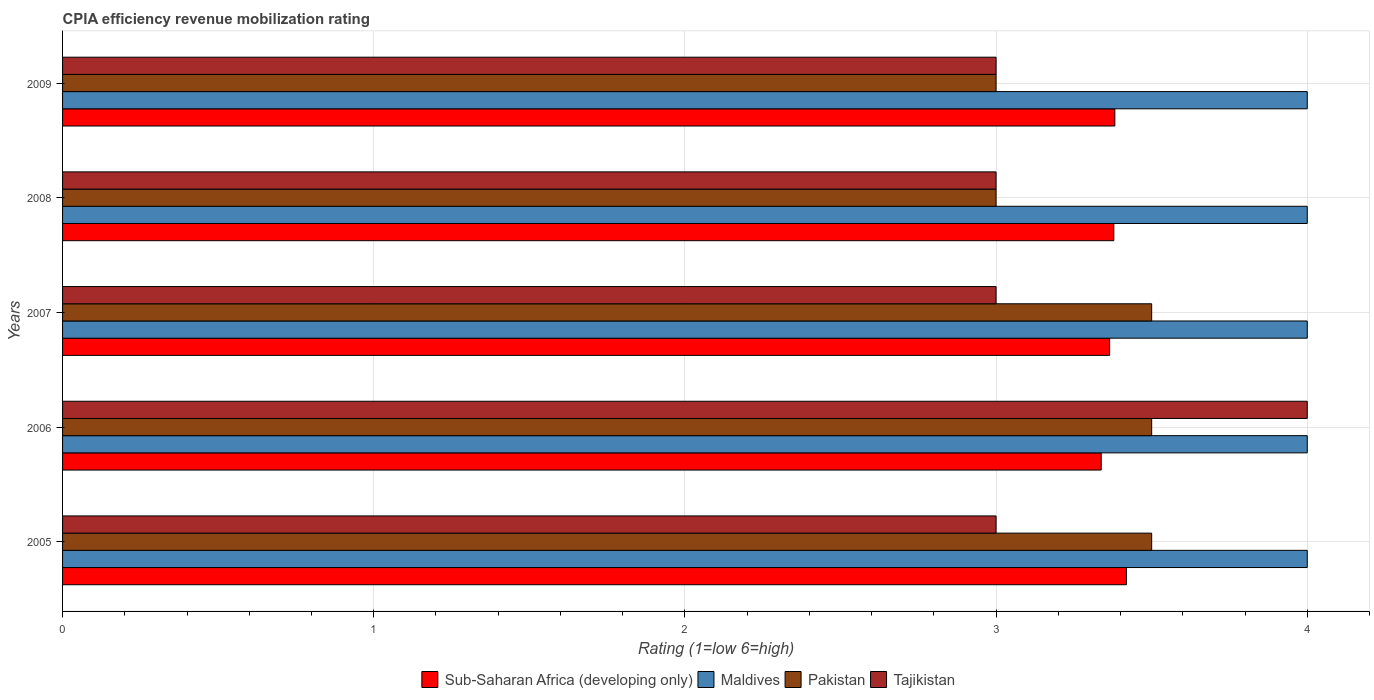How many groups of bars are there?
Keep it short and to the point. 5. Are the number of bars per tick equal to the number of legend labels?
Ensure brevity in your answer.  Yes. Are the number of bars on each tick of the Y-axis equal?
Offer a very short reply. Yes. How many bars are there on the 3rd tick from the top?
Offer a terse response. 4. What is the CPIA rating in Tajikistan in 2005?
Offer a very short reply. 3. Across all years, what is the maximum CPIA rating in Sub-Saharan Africa (developing only)?
Your response must be concise. 3.42. Across all years, what is the minimum CPIA rating in Pakistan?
Offer a very short reply. 3. In which year was the CPIA rating in Maldives maximum?
Ensure brevity in your answer.  2005. What is the difference between the CPIA rating in Sub-Saharan Africa (developing only) in 2005 and that in 2009?
Provide a short and direct response. 0.04. What is the difference between the CPIA rating in Pakistan in 2006 and the CPIA rating in Maldives in 2009?
Your answer should be very brief. -0.5. What is the average CPIA rating in Pakistan per year?
Your answer should be compact. 3.3. In the year 2009, what is the difference between the CPIA rating in Maldives and CPIA rating in Sub-Saharan Africa (developing only)?
Make the answer very short. 0.62. In how many years, is the CPIA rating in Tajikistan greater than 0.2 ?
Your response must be concise. 5. What is the ratio of the CPIA rating in Pakistan in 2007 to that in 2008?
Your answer should be compact. 1.17. What is the difference between the highest and the second highest CPIA rating in Sub-Saharan Africa (developing only)?
Your answer should be very brief. 0.04. What does the 3rd bar from the top in 2008 represents?
Provide a short and direct response. Maldives. What does the 4th bar from the bottom in 2008 represents?
Your answer should be very brief. Tajikistan. Is it the case that in every year, the sum of the CPIA rating in Maldives and CPIA rating in Tajikistan is greater than the CPIA rating in Pakistan?
Your answer should be very brief. Yes. How many bars are there?
Provide a succinct answer. 20. How many years are there in the graph?
Offer a very short reply. 5. What is the difference between two consecutive major ticks on the X-axis?
Keep it short and to the point. 1. Are the values on the major ticks of X-axis written in scientific E-notation?
Make the answer very short. No. Where does the legend appear in the graph?
Give a very brief answer. Bottom center. How many legend labels are there?
Make the answer very short. 4. How are the legend labels stacked?
Provide a succinct answer. Horizontal. What is the title of the graph?
Provide a succinct answer. CPIA efficiency revenue mobilization rating. What is the Rating (1=low 6=high) of Sub-Saharan Africa (developing only) in 2005?
Your response must be concise. 3.42. What is the Rating (1=low 6=high) of Pakistan in 2005?
Keep it short and to the point. 3.5. What is the Rating (1=low 6=high) of Sub-Saharan Africa (developing only) in 2006?
Provide a short and direct response. 3.34. What is the Rating (1=low 6=high) in Maldives in 2006?
Make the answer very short. 4. What is the Rating (1=low 6=high) in Pakistan in 2006?
Offer a very short reply. 3.5. What is the Rating (1=low 6=high) of Sub-Saharan Africa (developing only) in 2007?
Ensure brevity in your answer.  3.36. What is the Rating (1=low 6=high) in Pakistan in 2007?
Provide a short and direct response. 3.5. What is the Rating (1=low 6=high) in Tajikistan in 2007?
Your response must be concise. 3. What is the Rating (1=low 6=high) in Sub-Saharan Africa (developing only) in 2008?
Provide a short and direct response. 3.38. What is the Rating (1=low 6=high) of Tajikistan in 2008?
Your answer should be compact. 3. What is the Rating (1=low 6=high) of Sub-Saharan Africa (developing only) in 2009?
Keep it short and to the point. 3.38. Across all years, what is the maximum Rating (1=low 6=high) in Sub-Saharan Africa (developing only)?
Your response must be concise. 3.42. Across all years, what is the maximum Rating (1=low 6=high) in Pakistan?
Your answer should be very brief. 3.5. Across all years, what is the maximum Rating (1=low 6=high) in Tajikistan?
Ensure brevity in your answer.  4. Across all years, what is the minimum Rating (1=low 6=high) of Sub-Saharan Africa (developing only)?
Provide a short and direct response. 3.34. Across all years, what is the minimum Rating (1=low 6=high) in Maldives?
Ensure brevity in your answer.  4. Across all years, what is the minimum Rating (1=low 6=high) of Pakistan?
Keep it short and to the point. 3. What is the total Rating (1=low 6=high) of Sub-Saharan Africa (developing only) in the graph?
Give a very brief answer. 16.88. What is the total Rating (1=low 6=high) of Maldives in the graph?
Your answer should be compact. 20. What is the difference between the Rating (1=low 6=high) of Sub-Saharan Africa (developing only) in 2005 and that in 2006?
Make the answer very short. 0.08. What is the difference between the Rating (1=low 6=high) in Tajikistan in 2005 and that in 2006?
Provide a succinct answer. -1. What is the difference between the Rating (1=low 6=high) of Sub-Saharan Africa (developing only) in 2005 and that in 2007?
Your answer should be compact. 0.05. What is the difference between the Rating (1=low 6=high) in Maldives in 2005 and that in 2007?
Your response must be concise. 0. What is the difference between the Rating (1=low 6=high) in Pakistan in 2005 and that in 2007?
Offer a very short reply. 0. What is the difference between the Rating (1=low 6=high) of Sub-Saharan Africa (developing only) in 2005 and that in 2008?
Make the answer very short. 0.04. What is the difference between the Rating (1=low 6=high) of Tajikistan in 2005 and that in 2008?
Your answer should be very brief. 0. What is the difference between the Rating (1=low 6=high) in Sub-Saharan Africa (developing only) in 2005 and that in 2009?
Give a very brief answer. 0.04. What is the difference between the Rating (1=low 6=high) in Pakistan in 2005 and that in 2009?
Provide a short and direct response. 0.5. What is the difference between the Rating (1=low 6=high) of Tajikistan in 2005 and that in 2009?
Your response must be concise. 0. What is the difference between the Rating (1=low 6=high) in Sub-Saharan Africa (developing only) in 2006 and that in 2007?
Your answer should be very brief. -0.03. What is the difference between the Rating (1=low 6=high) in Pakistan in 2006 and that in 2007?
Provide a succinct answer. 0. What is the difference between the Rating (1=low 6=high) in Tajikistan in 2006 and that in 2007?
Offer a very short reply. 1. What is the difference between the Rating (1=low 6=high) of Sub-Saharan Africa (developing only) in 2006 and that in 2008?
Keep it short and to the point. -0.04. What is the difference between the Rating (1=low 6=high) in Maldives in 2006 and that in 2008?
Keep it short and to the point. 0. What is the difference between the Rating (1=low 6=high) in Pakistan in 2006 and that in 2008?
Give a very brief answer. 0.5. What is the difference between the Rating (1=low 6=high) in Tajikistan in 2006 and that in 2008?
Offer a terse response. 1. What is the difference between the Rating (1=low 6=high) in Sub-Saharan Africa (developing only) in 2006 and that in 2009?
Offer a very short reply. -0.04. What is the difference between the Rating (1=low 6=high) in Tajikistan in 2006 and that in 2009?
Keep it short and to the point. 1. What is the difference between the Rating (1=low 6=high) of Sub-Saharan Africa (developing only) in 2007 and that in 2008?
Your answer should be compact. -0.01. What is the difference between the Rating (1=low 6=high) of Maldives in 2007 and that in 2008?
Your answer should be very brief. 0. What is the difference between the Rating (1=low 6=high) of Pakistan in 2007 and that in 2008?
Your answer should be very brief. 0.5. What is the difference between the Rating (1=low 6=high) in Sub-Saharan Africa (developing only) in 2007 and that in 2009?
Provide a succinct answer. -0.02. What is the difference between the Rating (1=low 6=high) in Maldives in 2007 and that in 2009?
Your answer should be very brief. 0. What is the difference between the Rating (1=low 6=high) in Pakistan in 2007 and that in 2009?
Give a very brief answer. 0.5. What is the difference between the Rating (1=low 6=high) in Sub-Saharan Africa (developing only) in 2008 and that in 2009?
Offer a terse response. -0. What is the difference between the Rating (1=low 6=high) in Pakistan in 2008 and that in 2009?
Your response must be concise. 0. What is the difference between the Rating (1=low 6=high) in Tajikistan in 2008 and that in 2009?
Keep it short and to the point. 0. What is the difference between the Rating (1=low 6=high) in Sub-Saharan Africa (developing only) in 2005 and the Rating (1=low 6=high) in Maldives in 2006?
Offer a terse response. -0.58. What is the difference between the Rating (1=low 6=high) of Sub-Saharan Africa (developing only) in 2005 and the Rating (1=low 6=high) of Pakistan in 2006?
Ensure brevity in your answer.  -0.08. What is the difference between the Rating (1=low 6=high) in Sub-Saharan Africa (developing only) in 2005 and the Rating (1=low 6=high) in Tajikistan in 2006?
Provide a succinct answer. -0.58. What is the difference between the Rating (1=low 6=high) of Maldives in 2005 and the Rating (1=low 6=high) of Pakistan in 2006?
Provide a succinct answer. 0.5. What is the difference between the Rating (1=low 6=high) in Sub-Saharan Africa (developing only) in 2005 and the Rating (1=low 6=high) in Maldives in 2007?
Your answer should be compact. -0.58. What is the difference between the Rating (1=low 6=high) in Sub-Saharan Africa (developing only) in 2005 and the Rating (1=low 6=high) in Pakistan in 2007?
Make the answer very short. -0.08. What is the difference between the Rating (1=low 6=high) of Sub-Saharan Africa (developing only) in 2005 and the Rating (1=low 6=high) of Tajikistan in 2007?
Your response must be concise. 0.42. What is the difference between the Rating (1=low 6=high) in Maldives in 2005 and the Rating (1=low 6=high) in Tajikistan in 2007?
Offer a very short reply. 1. What is the difference between the Rating (1=low 6=high) of Sub-Saharan Africa (developing only) in 2005 and the Rating (1=low 6=high) of Maldives in 2008?
Offer a very short reply. -0.58. What is the difference between the Rating (1=low 6=high) of Sub-Saharan Africa (developing only) in 2005 and the Rating (1=low 6=high) of Pakistan in 2008?
Keep it short and to the point. 0.42. What is the difference between the Rating (1=low 6=high) in Sub-Saharan Africa (developing only) in 2005 and the Rating (1=low 6=high) in Tajikistan in 2008?
Your answer should be very brief. 0.42. What is the difference between the Rating (1=low 6=high) in Sub-Saharan Africa (developing only) in 2005 and the Rating (1=low 6=high) in Maldives in 2009?
Offer a terse response. -0.58. What is the difference between the Rating (1=low 6=high) in Sub-Saharan Africa (developing only) in 2005 and the Rating (1=low 6=high) in Pakistan in 2009?
Offer a very short reply. 0.42. What is the difference between the Rating (1=low 6=high) in Sub-Saharan Africa (developing only) in 2005 and the Rating (1=low 6=high) in Tajikistan in 2009?
Give a very brief answer. 0.42. What is the difference between the Rating (1=low 6=high) of Maldives in 2005 and the Rating (1=low 6=high) of Pakistan in 2009?
Give a very brief answer. 1. What is the difference between the Rating (1=low 6=high) in Maldives in 2005 and the Rating (1=low 6=high) in Tajikistan in 2009?
Offer a terse response. 1. What is the difference between the Rating (1=low 6=high) in Pakistan in 2005 and the Rating (1=low 6=high) in Tajikistan in 2009?
Offer a very short reply. 0.5. What is the difference between the Rating (1=low 6=high) of Sub-Saharan Africa (developing only) in 2006 and the Rating (1=low 6=high) of Maldives in 2007?
Give a very brief answer. -0.66. What is the difference between the Rating (1=low 6=high) in Sub-Saharan Africa (developing only) in 2006 and the Rating (1=low 6=high) in Pakistan in 2007?
Keep it short and to the point. -0.16. What is the difference between the Rating (1=low 6=high) in Sub-Saharan Africa (developing only) in 2006 and the Rating (1=low 6=high) in Tajikistan in 2007?
Provide a short and direct response. 0.34. What is the difference between the Rating (1=low 6=high) in Maldives in 2006 and the Rating (1=low 6=high) in Pakistan in 2007?
Offer a very short reply. 0.5. What is the difference between the Rating (1=low 6=high) of Maldives in 2006 and the Rating (1=low 6=high) of Tajikistan in 2007?
Your response must be concise. 1. What is the difference between the Rating (1=low 6=high) of Pakistan in 2006 and the Rating (1=low 6=high) of Tajikistan in 2007?
Make the answer very short. 0.5. What is the difference between the Rating (1=low 6=high) in Sub-Saharan Africa (developing only) in 2006 and the Rating (1=low 6=high) in Maldives in 2008?
Keep it short and to the point. -0.66. What is the difference between the Rating (1=low 6=high) in Sub-Saharan Africa (developing only) in 2006 and the Rating (1=low 6=high) in Pakistan in 2008?
Offer a very short reply. 0.34. What is the difference between the Rating (1=low 6=high) in Sub-Saharan Africa (developing only) in 2006 and the Rating (1=low 6=high) in Tajikistan in 2008?
Keep it short and to the point. 0.34. What is the difference between the Rating (1=low 6=high) in Maldives in 2006 and the Rating (1=low 6=high) in Tajikistan in 2008?
Provide a succinct answer. 1. What is the difference between the Rating (1=low 6=high) of Sub-Saharan Africa (developing only) in 2006 and the Rating (1=low 6=high) of Maldives in 2009?
Your response must be concise. -0.66. What is the difference between the Rating (1=low 6=high) in Sub-Saharan Africa (developing only) in 2006 and the Rating (1=low 6=high) in Pakistan in 2009?
Keep it short and to the point. 0.34. What is the difference between the Rating (1=low 6=high) of Sub-Saharan Africa (developing only) in 2006 and the Rating (1=low 6=high) of Tajikistan in 2009?
Provide a succinct answer. 0.34. What is the difference between the Rating (1=low 6=high) in Maldives in 2006 and the Rating (1=low 6=high) in Pakistan in 2009?
Keep it short and to the point. 1. What is the difference between the Rating (1=low 6=high) in Pakistan in 2006 and the Rating (1=low 6=high) in Tajikistan in 2009?
Offer a very short reply. 0.5. What is the difference between the Rating (1=low 6=high) in Sub-Saharan Africa (developing only) in 2007 and the Rating (1=low 6=high) in Maldives in 2008?
Provide a short and direct response. -0.64. What is the difference between the Rating (1=low 6=high) in Sub-Saharan Africa (developing only) in 2007 and the Rating (1=low 6=high) in Pakistan in 2008?
Your answer should be very brief. 0.36. What is the difference between the Rating (1=low 6=high) of Sub-Saharan Africa (developing only) in 2007 and the Rating (1=low 6=high) of Tajikistan in 2008?
Make the answer very short. 0.36. What is the difference between the Rating (1=low 6=high) of Maldives in 2007 and the Rating (1=low 6=high) of Pakistan in 2008?
Provide a succinct answer. 1. What is the difference between the Rating (1=low 6=high) of Sub-Saharan Africa (developing only) in 2007 and the Rating (1=low 6=high) of Maldives in 2009?
Keep it short and to the point. -0.64. What is the difference between the Rating (1=low 6=high) in Sub-Saharan Africa (developing only) in 2007 and the Rating (1=low 6=high) in Pakistan in 2009?
Provide a succinct answer. 0.36. What is the difference between the Rating (1=low 6=high) of Sub-Saharan Africa (developing only) in 2007 and the Rating (1=low 6=high) of Tajikistan in 2009?
Make the answer very short. 0.36. What is the difference between the Rating (1=low 6=high) in Maldives in 2007 and the Rating (1=low 6=high) in Pakistan in 2009?
Give a very brief answer. 1. What is the difference between the Rating (1=low 6=high) of Maldives in 2007 and the Rating (1=low 6=high) of Tajikistan in 2009?
Your response must be concise. 1. What is the difference between the Rating (1=low 6=high) of Pakistan in 2007 and the Rating (1=low 6=high) of Tajikistan in 2009?
Provide a short and direct response. 0.5. What is the difference between the Rating (1=low 6=high) of Sub-Saharan Africa (developing only) in 2008 and the Rating (1=low 6=high) of Maldives in 2009?
Keep it short and to the point. -0.62. What is the difference between the Rating (1=low 6=high) of Sub-Saharan Africa (developing only) in 2008 and the Rating (1=low 6=high) of Pakistan in 2009?
Provide a short and direct response. 0.38. What is the difference between the Rating (1=low 6=high) in Sub-Saharan Africa (developing only) in 2008 and the Rating (1=low 6=high) in Tajikistan in 2009?
Ensure brevity in your answer.  0.38. What is the difference between the Rating (1=low 6=high) in Maldives in 2008 and the Rating (1=low 6=high) in Tajikistan in 2009?
Keep it short and to the point. 1. What is the difference between the Rating (1=low 6=high) of Pakistan in 2008 and the Rating (1=low 6=high) of Tajikistan in 2009?
Make the answer very short. 0. What is the average Rating (1=low 6=high) in Sub-Saharan Africa (developing only) per year?
Offer a terse response. 3.38. What is the average Rating (1=low 6=high) in Maldives per year?
Ensure brevity in your answer.  4. In the year 2005, what is the difference between the Rating (1=low 6=high) in Sub-Saharan Africa (developing only) and Rating (1=low 6=high) in Maldives?
Provide a short and direct response. -0.58. In the year 2005, what is the difference between the Rating (1=low 6=high) in Sub-Saharan Africa (developing only) and Rating (1=low 6=high) in Pakistan?
Give a very brief answer. -0.08. In the year 2005, what is the difference between the Rating (1=low 6=high) of Sub-Saharan Africa (developing only) and Rating (1=low 6=high) of Tajikistan?
Your answer should be compact. 0.42. In the year 2006, what is the difference between the Rating (1=low 6=high) in Sub-Saharan Africa (developing only) and Rating (1=low 6=high) in Maldives?
Your answer should be compact. -0.66. In the year 2006, what is the difference between the Rating (1=low 6=high) of Sub-Saharan Africa (developing only) and Rating (1=low 6=high) of Pakistan?
Give a very brief answer. -0.16. In the year 2006, what is the difference between the Rating (1=low 6=high) of Sub-Saharan Africa (developing only) and Rating (1=low 6=high) of Tajikistan?
Your answer should be compact. -0.66. In the year 2006, what is the difference between the Rating (1=low 6=high) of Maldives and Rating (1=low 6=high) of Pakistan?
Provide a succinct answer. 0.5. In the year 2006, what is the difference between the Rating (1=low 6=high) in Maldives and Rating (1=low 6=high) in Tajikistan?
Keep it short and to the point. 0. In the year 2007, what is the difference between the Rating (1=low 6=high) in Sub-Saharan Africa (developing only) and Rating (1=low 6=high) in Maldives?
Provide a short and direct response. -0.64. In the year 2007, what is the difference between the Rating (1=low 6=high) of Sub-Saharan Africa (developing only) and Rating (1=low 6=high) of Pakistan?
Offer a terse response. -0.14. In the year 2007, what is the difference between the Rating (1=low 6=high) in Sub-Saharan Africa (developing only) and Rating (1=low 6=high) in Tajikistan?
Your answer should be compact. 0.36. In the year 2007, what is the difference between the Rating (1=low 6=high) in Maldives and Rating (1=low 6=high) in Pakistan?
Provide a short and direct response. 0.5. In the year 2007, what is the difference between the Rating (1=low 6=high) of Pakistan and Rating (1=low 6=high) of Tajikistan?
Provide a short and direct response. 0.5. In the year 2008, what is the difference between the Rating (1=low 6=high) of Sub-Saharan Africa (developing only) and Rating (1=low 6=high) of Maldives?
Give a very brief answer. -0.62. In the year 2008, what is the difference between the Rating (1=low 6=high) of Sub-Saharan Africa (developing only) and Rating (1=low 6=high) of Pakistan?
Your answer should be very brief. 0.38. In the year 2008, what is the difference between the Rating (1=low 6=high) in Sub-Saharan Africa (developing only) and Rating (1=low 6=high) in Tajikistan?
Give a very brief answer. 0.38. In the year 2008, what is the difference between the Rating (1=low 6=high) of Maldives and Rating (1=low 6=high) of Pakistan?
Make the answer very short. 1. In the year 2008, what is the difference between the Rating (1=low 6=high) in Maldives and Rating (1=low 6=high) in Tajikistan?
Provide a short and direct response. 1. In the year 2008, what is the difference between the Rating (1=low 6=high) of Pakistan and Rating (1=low 6=high) of Tajikistan?
Ensure brevity in your answer.  0. In the year 2009, what is the difference between the Rating (1=low 6=high) of Sub-Saharan Africa (developing only) and Rating (1=low 6=high) of Maldives?
Make the answer very short. -0.62. In the year 2009, what is the difference between the Rating (1=low 6=high) of Sub-Saharan Africa (developing only) and Rating (1=low 6=high) of Pakistan?
Give a very brief answer. 0.38. In the year 2009, what is the difference between the Rating (1=low 6=high) of Sub-Saharan Africa (developing only) and Rating (1=low 6=high) of Tajikistan?
Provide a succinct answer. 0.38. In the year 2009, what is the difference between the Rating (1=low 6=high) of Maldives and Rating (1=low 6=high) of Pakistan?
Provide a short and direct response. 1. In the year 2009, what is the difference between the Rating (1=low 6=high) of Pakistan and Rating (1=low 6=high) of Tajikistan?
Offer a terse response. 0. What is the ratio of the Rating (1=low 6=high) of Sub-Saharan Africa (developing only) in 2005 to that in 2006?
Ensure brevity in your answer.  1.02. What is the ratio of the Rating (1=low 6=high) in Pakistan in 2005 to that in 2006?
Keep it short and to the point. 1. What is the ratio of the Rating (1=low 6=high) of Tajikistan in 2005 to that in 2006?
Make the answer very short. 0.75. What is the ratio of the Rating (1=low 6=high) of Sub-Saharan Africa (developing only) in 2005 to that in 2007?
Ensure brevity in your answer.  1.02. What is the ratio of the Rating (1=low 6=high) in Maldives in 2005 to that in 2007?
Provide a short and direct response. 1. What is the ratio of the Rating (1=low 6=high) of Pakistan in 2005 to that in 2007?
Your response must be concise. 1. What is the ratio of the Rating (1=low 6=high) in Sub-Saharan Africa (developing only) in 2005 to that in 2008?
Your answer should be compact. 1.01. What is the ratio of the Rating (1=low 6=high) in Maldives in 2005 to that in 2008?
Your answer should be compact. 1. What is the ratio of the Rating (1=low 6=high) in Pakistan in 2005 to that in 2008?
Give a very brief answer. 1.17. What is the ratio of the Rating (1=low 6=high) in Tajikistan in 2005 to that in 2008?
Your response must be concise. 1. What is the ratio of the Rating (1=low 6=high) of Sub-Saharan Africa (developing only) in 2005 to that in 2009?
Offer a very short reply. 1.01. What is the ratio of the Rating (1=low 6=high) in Maldives in 2006 to that in 2007?
Make the answer very short. 1. What is the ratio of the Rating (1=low 6=high) in Pakistan in 2006 to that in 2007?
Give a very brief answer. 1. What is the ratio of the Rating (1=low 6=high) of Tajikistan in 2006 to that in 2007?
Keep it short and to the point. 1.33. What is the ratio of the Rating (1=low 6=high) of Tajikistan in 2006 to that in 2008?
Offer a very short reply. 1.33. What is the ratio of the Rating (1=low 6=high) of Sub-Saharan Africa (developing only) in 2006 to that in 2009?
Your answer should be very brief. 0.99. What is the ratio of the Rating (1=low 6=high) of Pakistan in 2007 to that in 2008?
Your response must be concise. 1.17. What is the ratio of the Rating (1=low 6=high) in Pakistan in 2007 to that in 2009?
Offer a terse response. 1.17. What is the ratio of the Rating (1=low 6=high) in Tajikistan in 2007 to that in 2009?
Make the answer very short. 1. What is the ratio of the Rating (1=low 6=high) in Maldives in 2008 to that in 2009?
Your answer should be compact. 1. What is the ratio of the Rating (1=low 6=high) of Pakistan in 2008 to that in 2009?
Keep it short and to the point. 1. What is the ratio of the Rating (1=low 6=high) of Tajikistan in 2008 to that in 2009?
Ensure brevity in your answer.  1. What is the difference between the highest and the second highest Rating (1=low 6=high) in Sub-Saharan Africa (developing only)?
Your answer should be compact. 0.04. What is the difference between the highest and the second highest Rating (1=low 6=high) of Maldives?
Your answer should be very brief. 0. What is the difference between the highest and the lowest Rating (1=low 6=high) in Sub-Saharan Africa (developing only)?
Your answer should be compact. 0.08. What is the difference between the highest and the lowest Rating (1=low 6=high) in Maldives?
Give a very brief answer. 0. What is the difference between the highest and the lowest Rating (1=low 6=high) of Pakistan?
Make the answer very short. 0.5. 